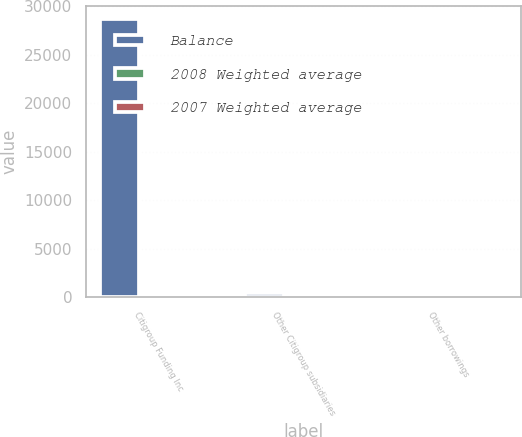Convert chart. <chart><loc_0><loc_0><loc_500><loc_500><stacked_bar_chart><ecel><fcel>Citigroup Funding Inc<fcel>Other Citigroup subsidiaries<fcel>Other borrowings<nl><fcel>Balance<fcel>28654<fcel>471<fcel>3.385<nl><fcel>2008 Weighted average<fcel>1.66<fcel>2.02<fcel>2.4<nl><fcel>2007 Weighted average<fcel>5.05<fcel>3.15<fcel>3.62<nl></chart> 